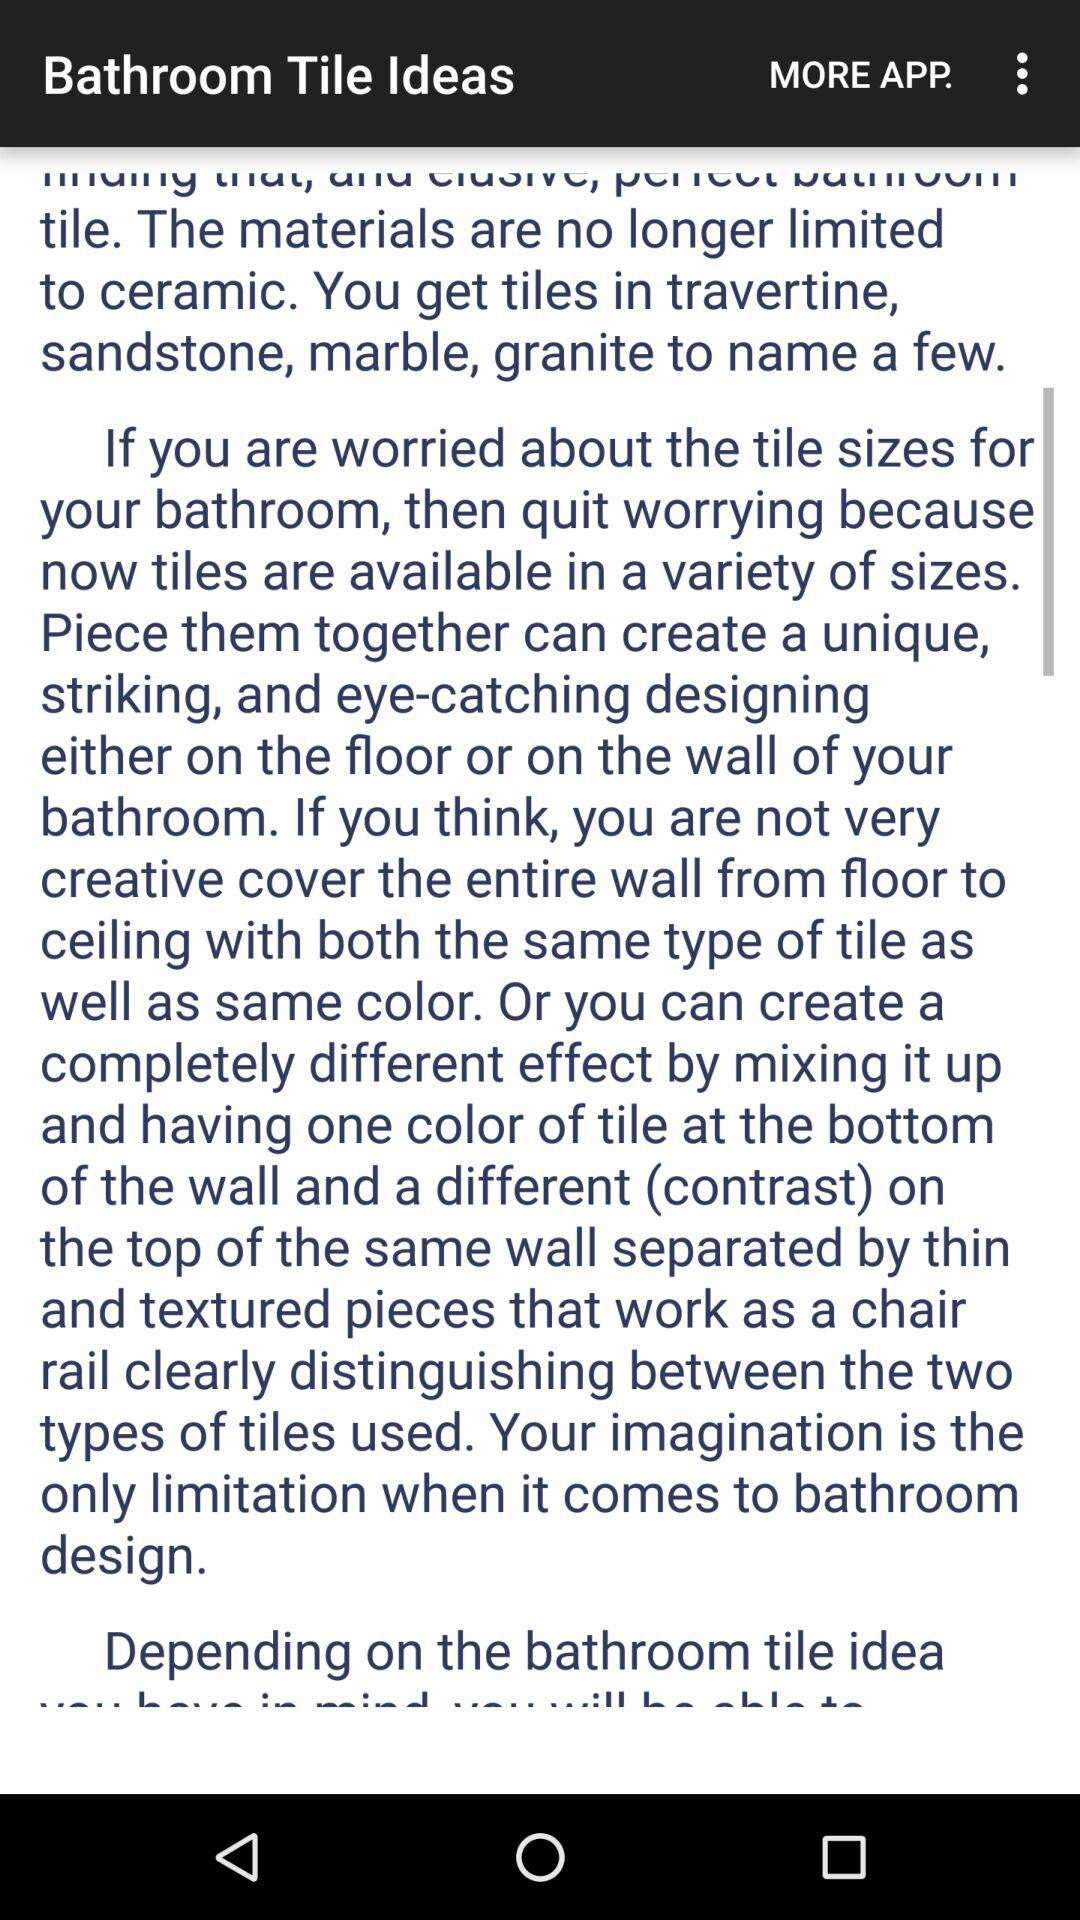What is the application name? The application name is "Bathroom Tile Ideas". 